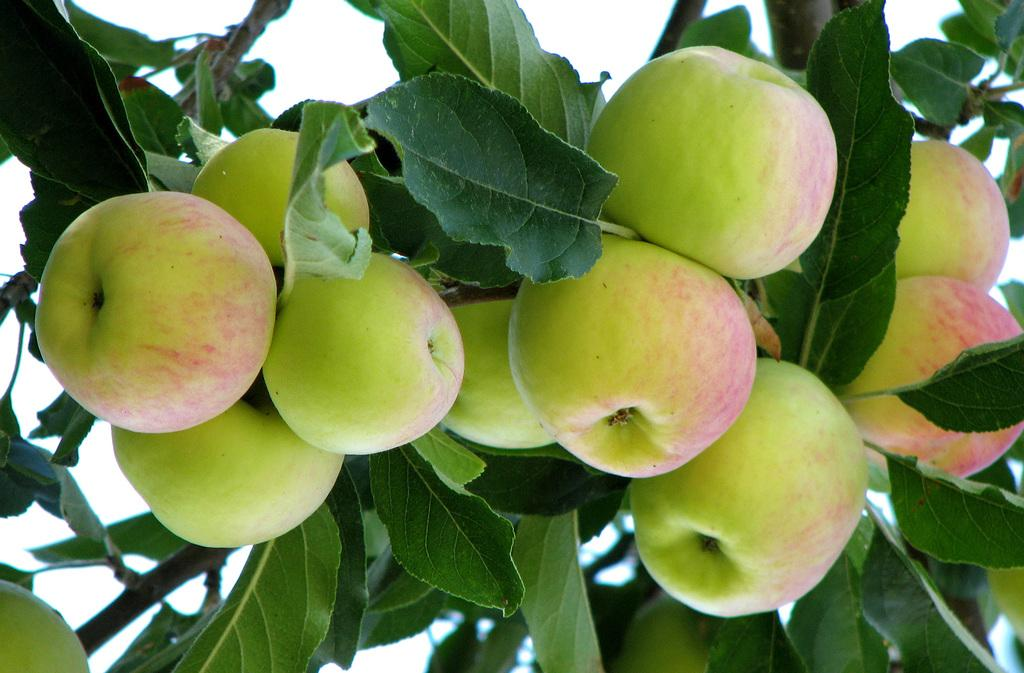What type of fruit is present in the image? There are apples in the image. What else can be seen on the apples in the image? There are leaves and stems in the image. What can be seen in the background of the image? The sky is visible in the background of the image. What type of religious ceremony is taking place in the image? There is no indication of a religious ceremony in the image; it features apples with leaves and stems, and a visible sky in the background. How many lizards can be seen in the image? There are no lizards present in the image. 